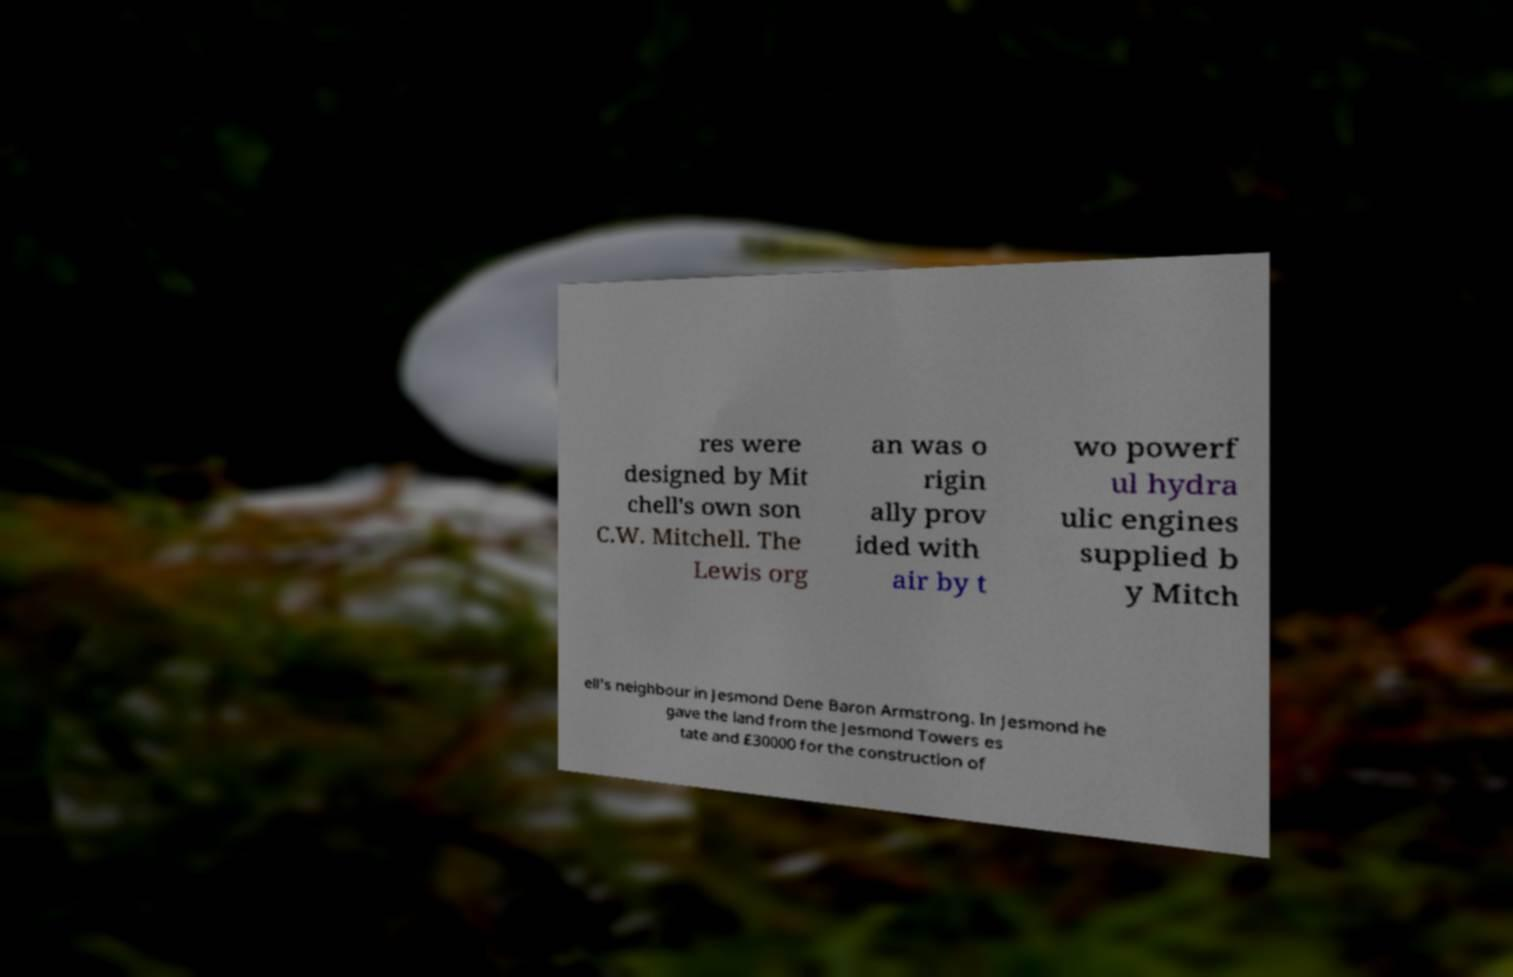There's text embedded in this image that I need extracted. Can you transcribe it verbatim? res were designed by Mit chell's own son C.W. Mitchell. The Lewis org an was o rigin ally prov ided with air by t wo powerf ul hydra ulic engines supplied b y Mitch ell's neighbour in Jesmond Dene Baron Armstrong. In Jesmond he gave the land from the Jesmond Towers es tate and £30000 for the construction of 